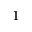<formula> <loc_0><loc_0><loc_500><loc_500>^ { 1 }</formula> 